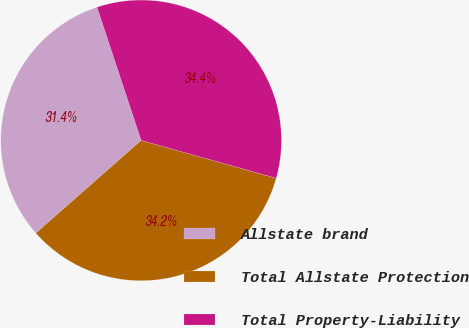<chart> <loc_0><loc_0><loc_500><loc_500><pie_chart><fcel>Allstate brand<fcel>Total Allstate Protection<fcel>Total Property-Liability<nl><fcel>31.4%<fcel>34.16%<fcel>34.44%<nl></chart> 